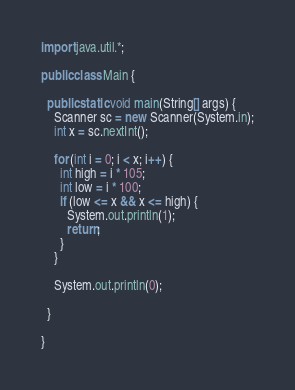Convert code to text. <code><loc_0><loc_0><loc_500><loc_500><_Java_>import java.util.*;

public class Main {

  public static void main(String[] args) {
    Scanner sc = new Scanner(System.in);
    int x = sc.nextInt();

    for (int i = 0; i < x; i++) {
      int high = i * 105;
      int low = i * 100;
      if (low <= x && x <= high) {
        System.out.println(1);
        return;
      }
    }

    System.out.println(0);

  }

}
</code> 